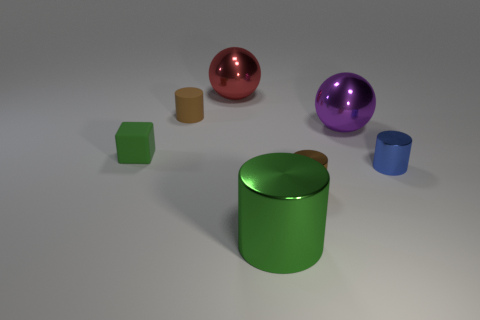The blue object that is made of the same material as the red ball is what size?
Your answer should be compact. Small. The red object has what size?
Your response must be concise. Large. What material is the tiny green block?
Your answer should be compact. Rubber. There is a red metal ball that is behind the purple object; is it the same size as the small green rubber cube?
Offer a very short reply. No. What number of objects are either brown matte cylinders or red matte cubes?
Give a very brief answer. 1. What shape is the small rubber thing that is the same color as the large cylinder?
Your answer should be compact. Cube. There is a object that is both to the right of the tiny brown metal cylinder and behind the green block; how big is it?
Offer a terse response. Large. What number of brown things are there?
Provide a succinct answer. 2. How many spheres are either purple objects or small brown things?
Your answer should be compact. 1. How many big things are on the left side of the brown thing in front of the brown cylinder that is left of the large green metallic thing?
Give a very brief answer. 2. 